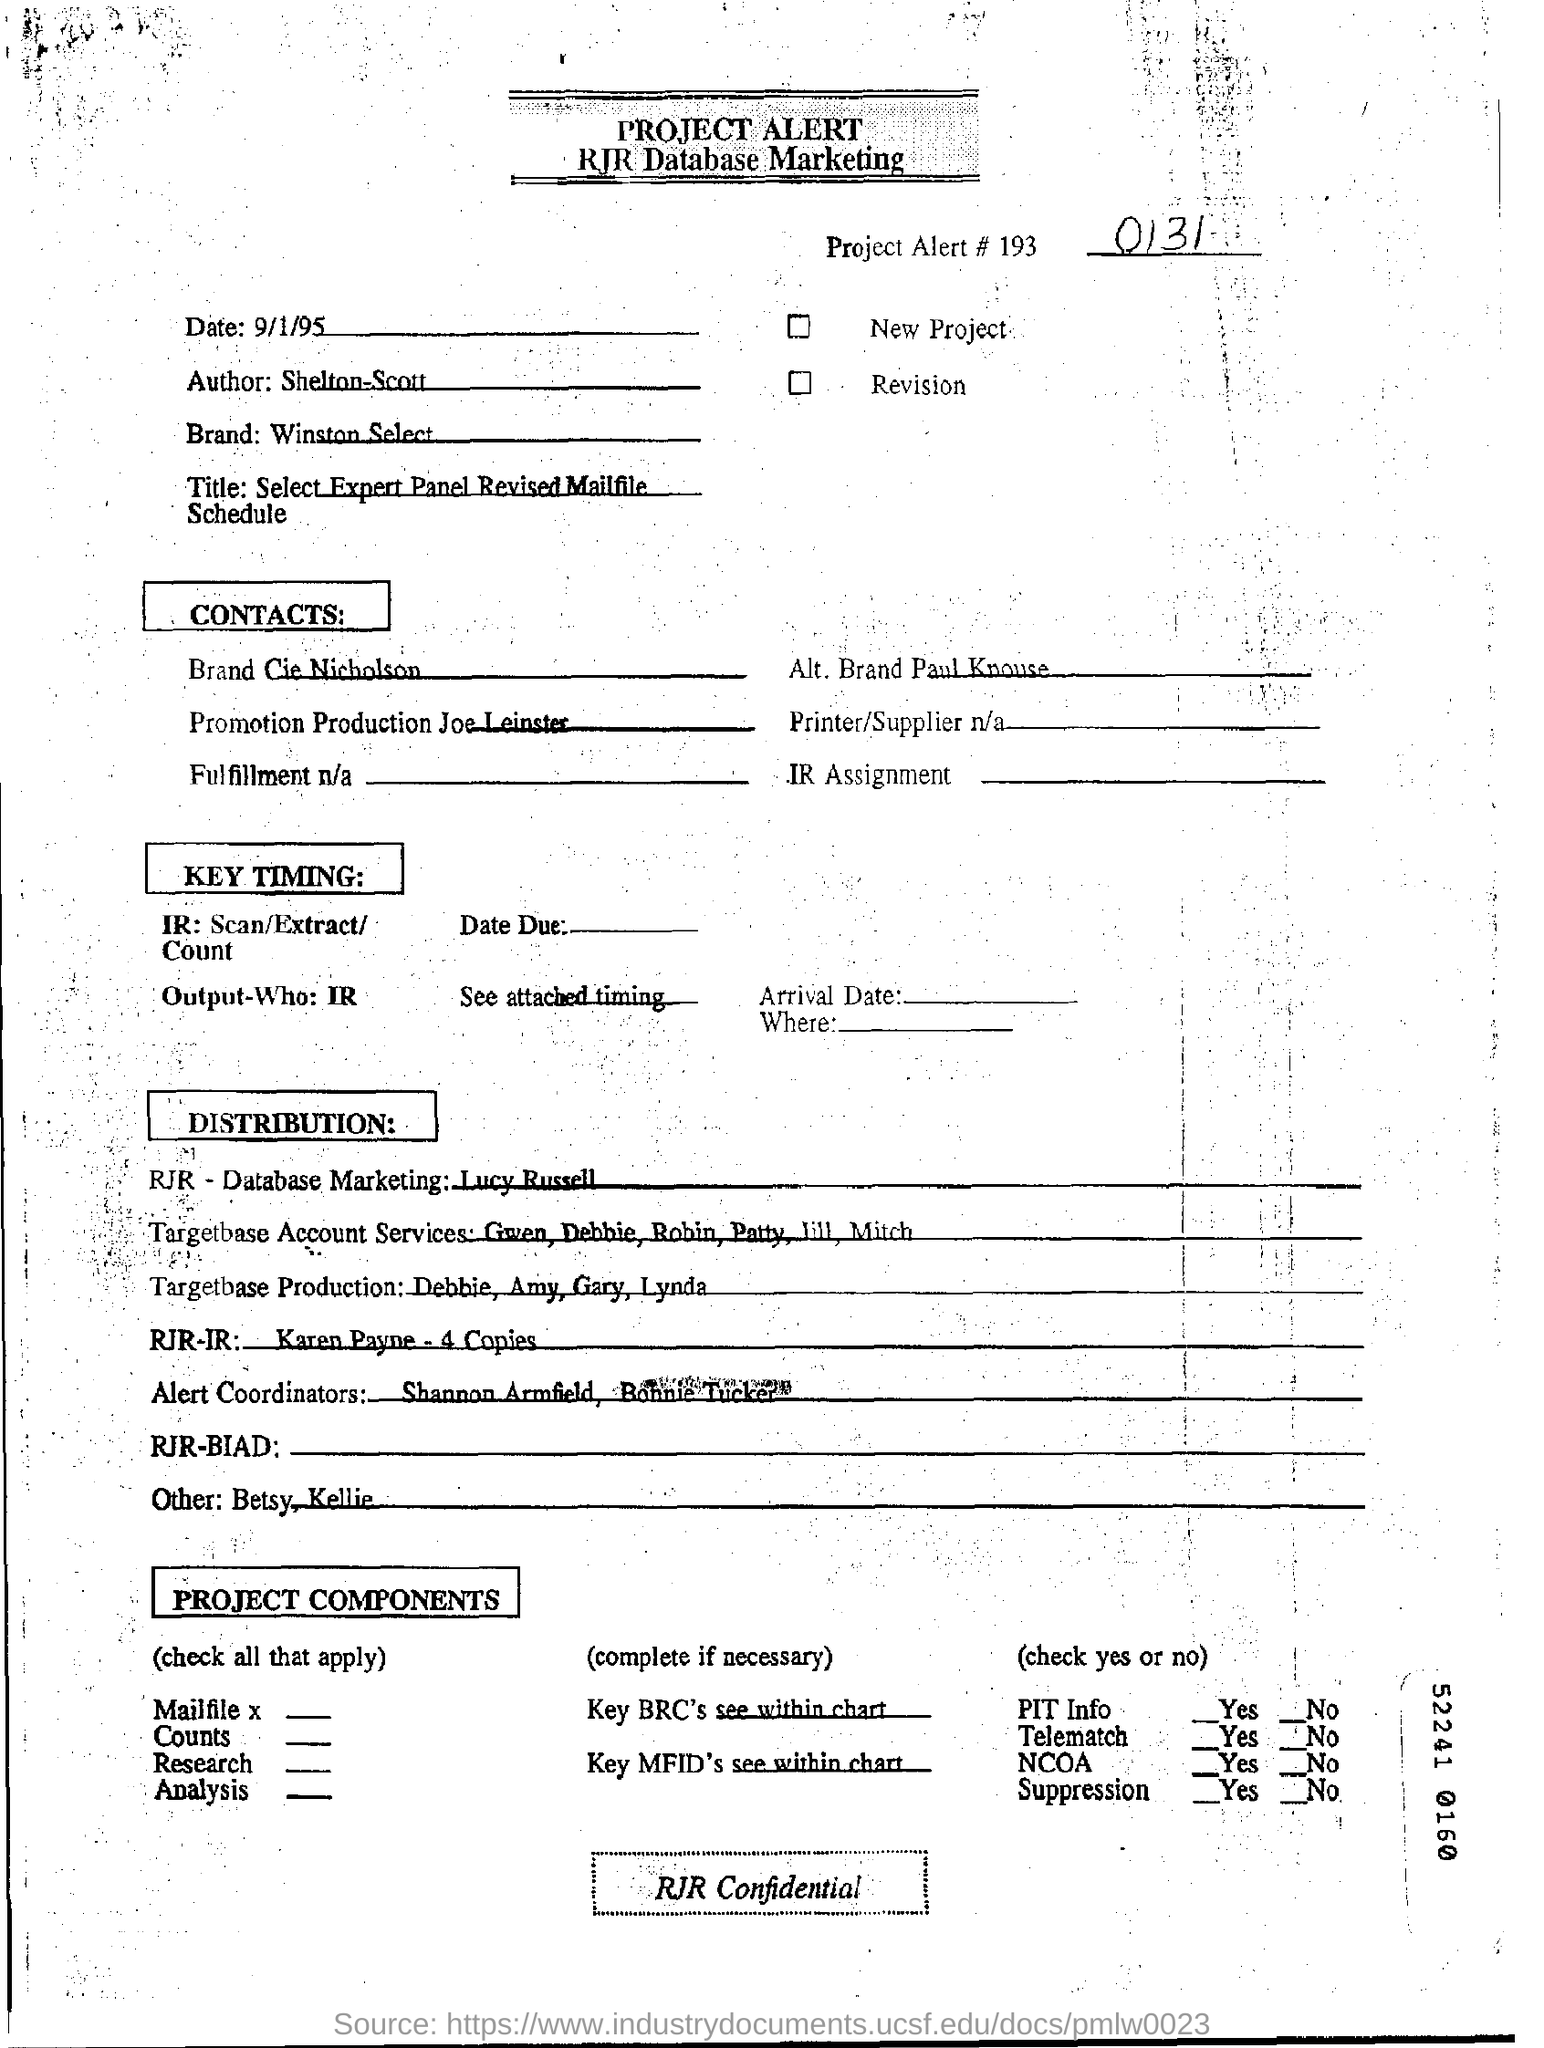Specify some key components in this picture. I am in possession of a brand called Winston Select. The name of the author is Shelton-Scott. What is the number of the project Alert#193?" is a question asking for information about a specific project. The speaker is seeking to know the number assigned to the project Alert#193. The date in the RJR Database marketing is September 1, 1995. 